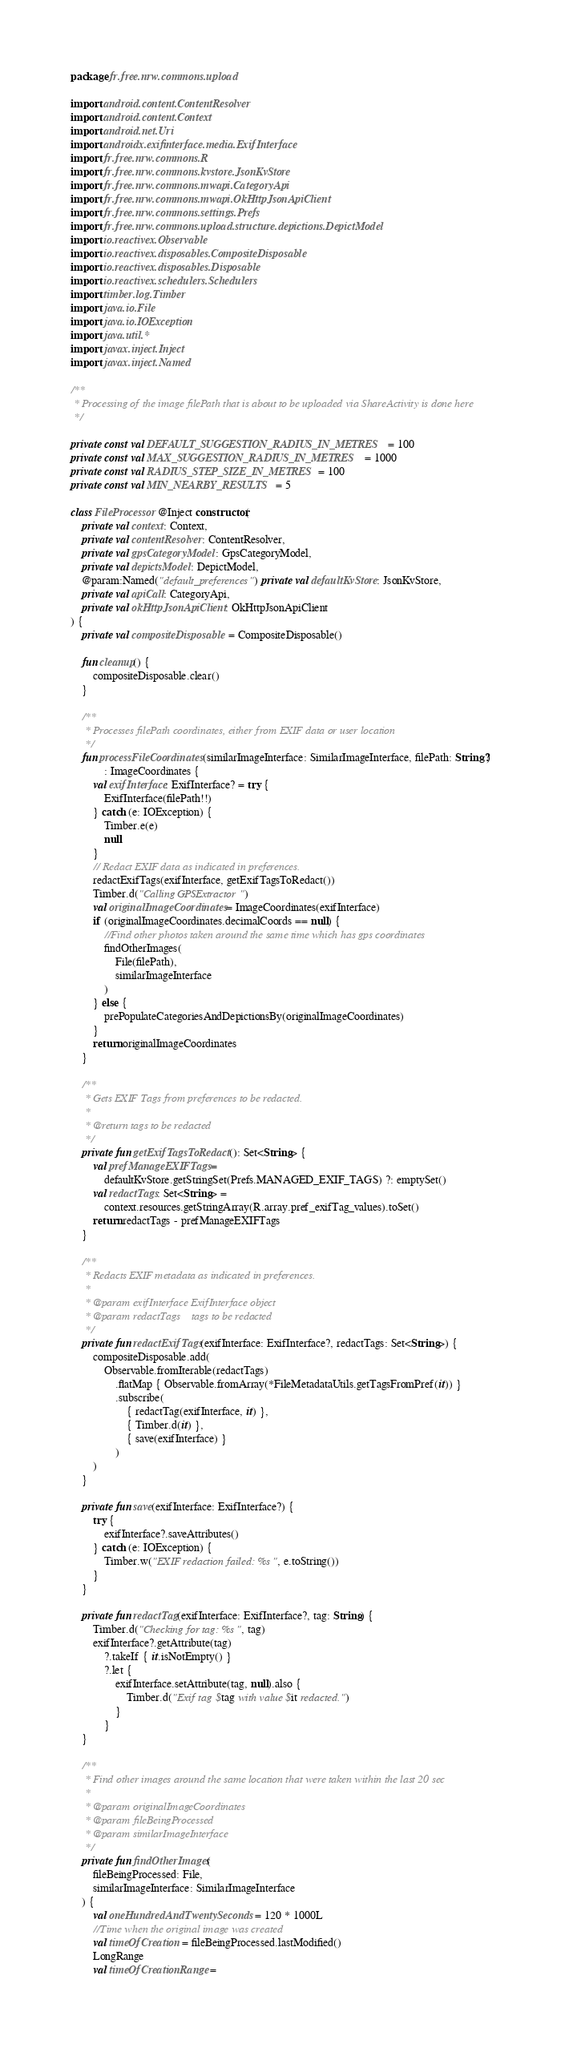<code> <loc_0><loc_0><loc_500><loc_500><_Kotlin_>package fr.free.nrw.commons.upload

import android.content.ContentResolver
import android.content.Context
import android.net.Uri
import androidx.exifinterface.media.ExifInterface
import fr.free.nrw.commons.R
import fr.free.nrw.commons.kvstore.JsonKvStore
import fr.free.nrw.commons.mwapi.CategoryApi
import fr.free.nrw.commons.mwapi.OkHttpJsonApiClient
import fr.free.nrw.commons.settings.Prefs
import fr.free.nrw.commons.upload.structure.depictions.DepictModel
import io.reactivex.Observable
import io.reactivex.disposables.CompositeDisposable
import io.reactivex.disposables.Disposable
import io.reactivex.schedulers.Schedulers
import timber.log.Timber
import java.io.File
import java.io.IOException
import java.util.*
import javax.inject.Inject
import javax.inject.Named

/**
 * Processing of the image filePath that is about to be uploaded via ShareActivity is done here
 */

private const val DEFAULT_SUGGESTION_RADIUS_IN_METRES = 100
private const val MAX_SUGGESTION_RADIUS_IN_METRES = 1000
private const val RADIUS_STEP_SIZE_IN_METRES = 100
private const val MIN_NEARBY_RESULTS = 5

class FileProcessor @Inject constructor(
    private val context: Context,
    private val contentResolver: ContentResolver,
    private val gpsCategoryModel: GpsCategoryModel,
    private val depictsModel: DepictModel,
    @param:Named("default_preferences") private val defaultKvStore: JsonKvStore,
    private val apiCall: CategoryApi,
    private val okHttpJsonApiClient: OkHttpJsonApiClient
) {
    private val compositeDisposable = CompositeDisposable()

    fun cleanup() {
        compositeDisposable.clear()
    }

    /**
     * Processes filePath coordinates, either from EXIF data or user location
     */
    fun processFileCoordinates(similarImageInterface: SimilarImageInterface, filePath: String?)
            : ImageCoordinates {
        val exifInterface: ExifInterface? = try {
            ExifInterface(filePath!!)
        } catch (e: IOException) {
            Timber.e(e)
            null
        }
        // Redact EXIF data as indicated in preferences.
        redactExifTags(exifInterface, getExifTagsToRedact())
        Timber.d("Calling GPSExtractor")
        val originalImageCoordinates = ImageCoordinates(exifInterface)
        if (originalImageCoordinates.decimalCoords == null) {
            //Find other photos taken around the same time which has gps coordinates
            findOtherImages(
                File(filePath),
                similarImageInterface
            )
        } else {
            prePopulateCategoriesAndDepictionsBy(originalImageCoordinates)
        }
        return originalImageCoordinates
    }

    /**
     * Gets EXIF Tags from preferences to be redacted.
     *
     * @return tags to be redacted
     */
    private fun getExifTagsToRedact(): Set<String> {
        val prefManageEXIFTags =
            defaultKvStore.getStringSet(Prefs.MANAGED_EXIF_TAGS) ?: emptySet()
        val redactTags: Set<String> =
            context.resources.getStringArray(R.array.pref_exifTag_values).toSet()
        return redactTags - prefManageEXIFTags
    }

    /**
     * Redacts EXIF metadata as indicated in preferences.
     *
     * @param exifInterface ExifInterface object
     * @param redactTags    tags to be redacted
     */
    private fun redactExifTags(exifInterface: ExifInterface?, redactTags: Set<String>) {
        compositeDisposable.add(
            Observable.fromIterable(redactTags)
                .flatMap { Observable.fromArray(*FileMetadataUtils.getTagsFromPref(it)) }
                .subscribe(
                    { redactTag(exifInterface, it) },
                    { Timber.d(it) },
                    { save(exifInterface) }
                )
        )
    }

    private fun save(exifInterface: ExifInterface?) {
        try {
            exifInterface?.saveAttributes()
        } catch (e: IOException) {
            Timber.w("EXIF redaction failed: %s", e.toString())
        }
    }

    private fun redactTag(exifInterface: ExifInterface?, tag: String) {
        Timber.d("Checking for tag: %s", tag)
        exifInterface?.getAttribute(tag)
            ?.takeIf { it.isNotEmpty() }
            ?.let {
                exifInterface.setAttribute(tag, null).also {
                    Timber.d("Exif tag $tag with value $it redacted.")
                }
            }
    }

    /**
     * Find other images around the same location that were taken within the last 20 sec
     *
     * @param originalImageCoordinates
     * @param fileBeingProcessed
     * @param similarImageInterface
     */
    private fun findOtherImages(
        fileBeingProcessed: File,
        similarImageInterface: SimilarImageInterface
    ) {
        val oneHundredAndTwentySeconds = 120 * 1000L
        //Time when the original image was created
        val timeOfCreation = fileBeingProcessed.lastModified()
        LongRange
        val timeOfCreationRange =</code> 